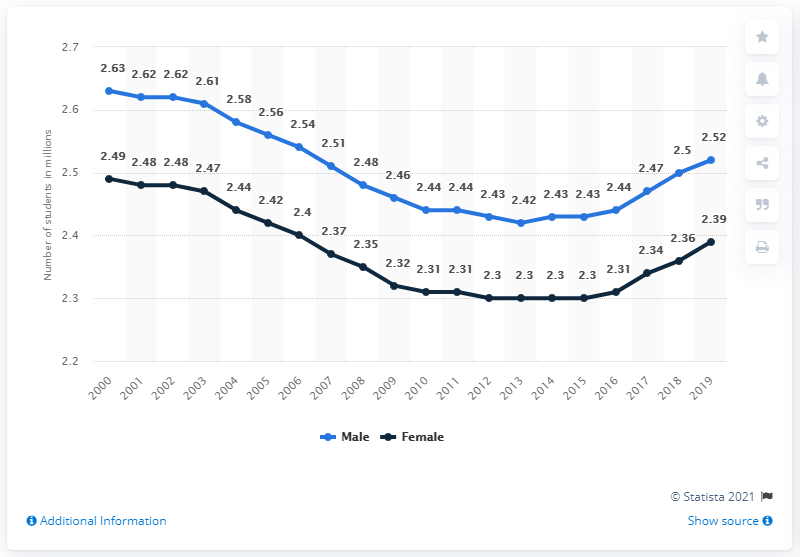Highlight a few significant elements in this photo. It is male gender that is greater in terms of mode. For each line, the lowest point is [2.3, 2.42]. In the 2018/2019 school year, there were 2,390 female students enrolled in public elementary and secondary schools in Canada. 